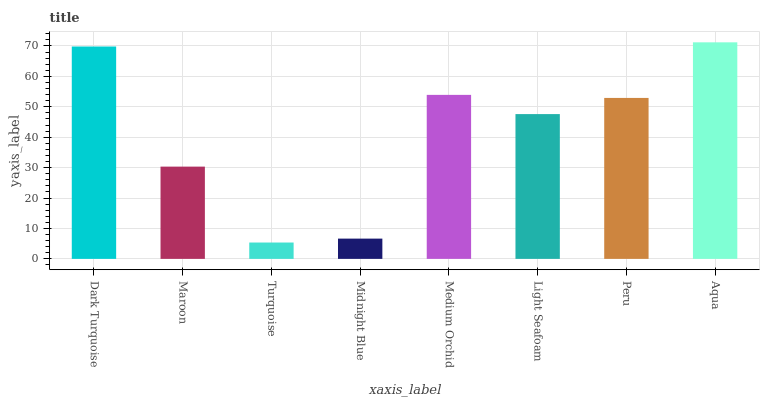Is Turquoise the minimum?
Answer yes or no. Yes. Is Aqua the maximum?
Answer yes or no. Yes. Is Maroon the minimum?
Answer yes or no. No. Is Maroon the maximum?
Answer yes or no. No. Is Dark Turquoise greater than Maroon?
Answer yes or no. Yes. Is Maroon less than Dark Turquoise?
Answer yes or no. Yes. Is Maroon greater than Dark Turquoise?
Answer yes or no. No. Is Dark Turquoise less than Maroon?
Answer yes or no. No. Is Peru the high median?
Answer yes or no. Yes. Is Light Seafoam the low median?
Answer yes or no. Yes. Is Dark Turquoise the high median?
Answer yes or no. No. Is Dark Turquoise the low median?
Answer yes or no. No. 